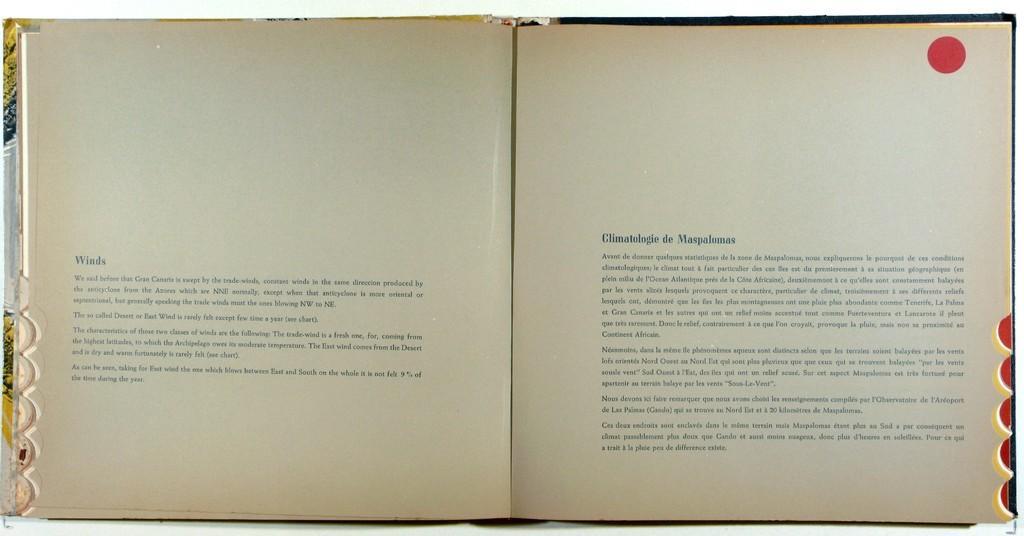Describe this image in one or two sentences. In this picture there is a book and there is text on the papers. 